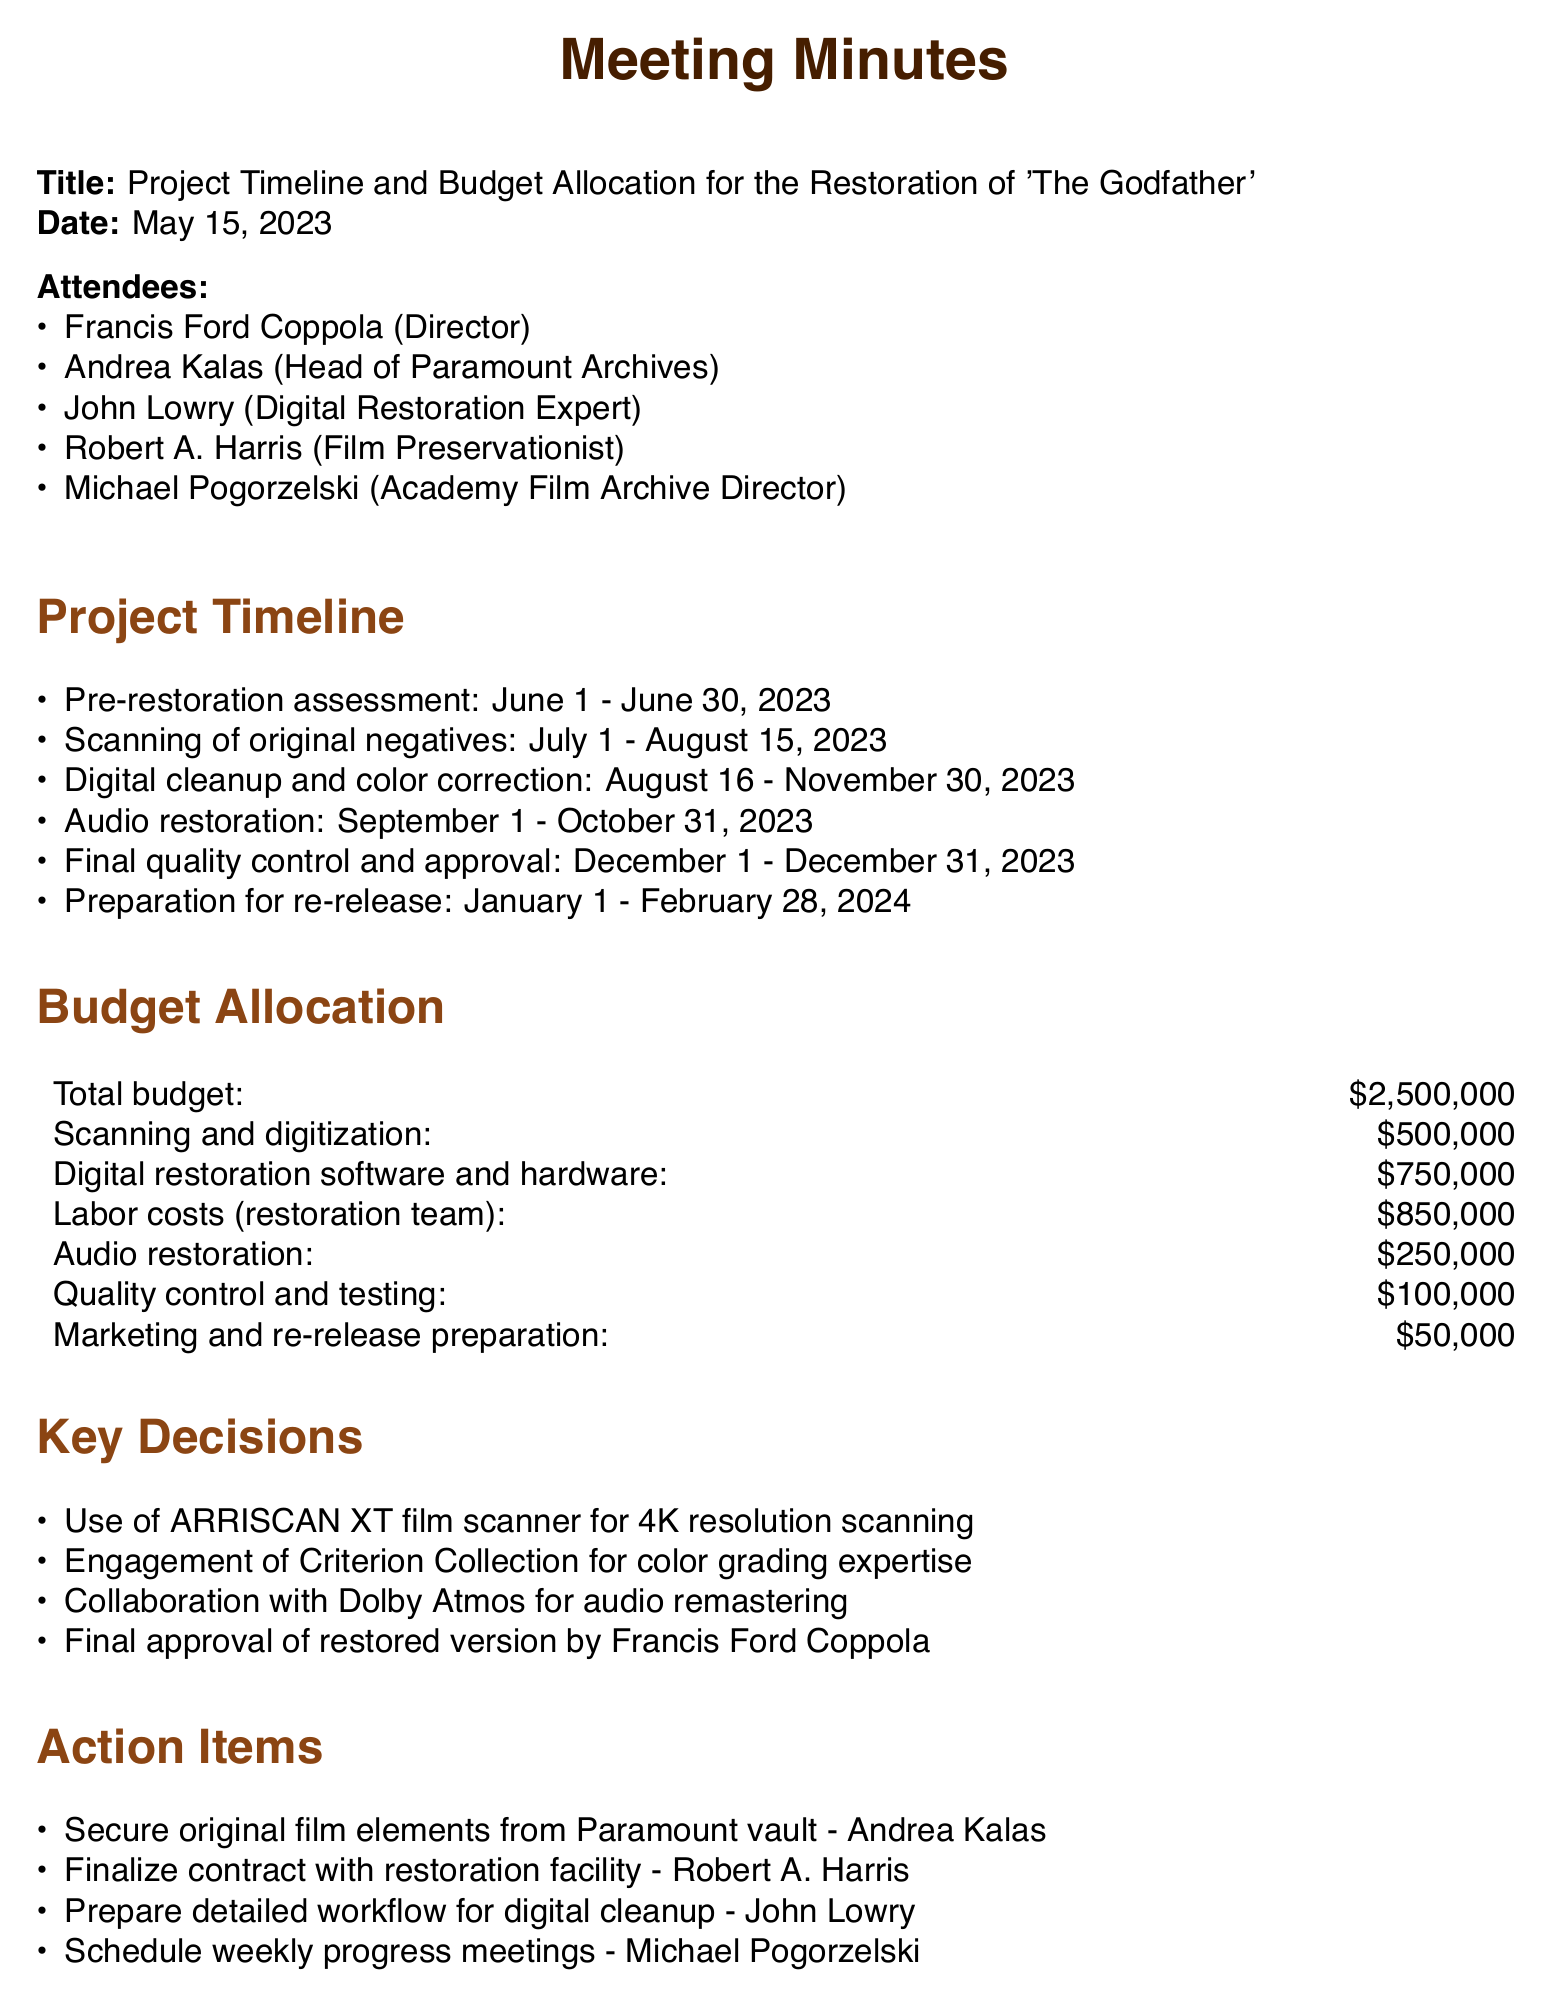What is the total budget for the restoration? The total budget is specifically mentioned in the document under the budget allocation section.
Answer: $2,500,000 What are the labor costs for the restoration team? The labor costs item is directly listed within the budget allocation details.
Answer: $850,000 Who is the Head of Paramount Archives? The document lists the attendees, where the position of the Head of Paramount Archives is stated.
Answer: Andrea Kalas When will the scanning of original negatives take place? The timeline for the scanning of original negatives is provided in the project timeline section.
Answer: July 1 - August 15, 2023 What is the purpose of the weekly progress meetings? The document states the action item to schedule weekly progress meetings, which focuses on the project's progress tracking.
Answer: Project progress Who is responsible for securing the original film elements? The action items detail who is assigned to secure the original film elements.
Answer: Andrea Kalas What expertise will the Criterion Collection provide? The document mentions a key decision regarding the engagement of Criterion Collection, indicating its role in the restoration process.
Answer: Color grading expertise During which month will final quality control and approval occur? The document specifies the timeline for final quality control and approval under the project timeline section.
Answer: December What scanning technology will be used for the restoration? The key decisions section refers to a specific technology that will be utilized for scanning.
Answer: ARRISCAN XT film scanner 